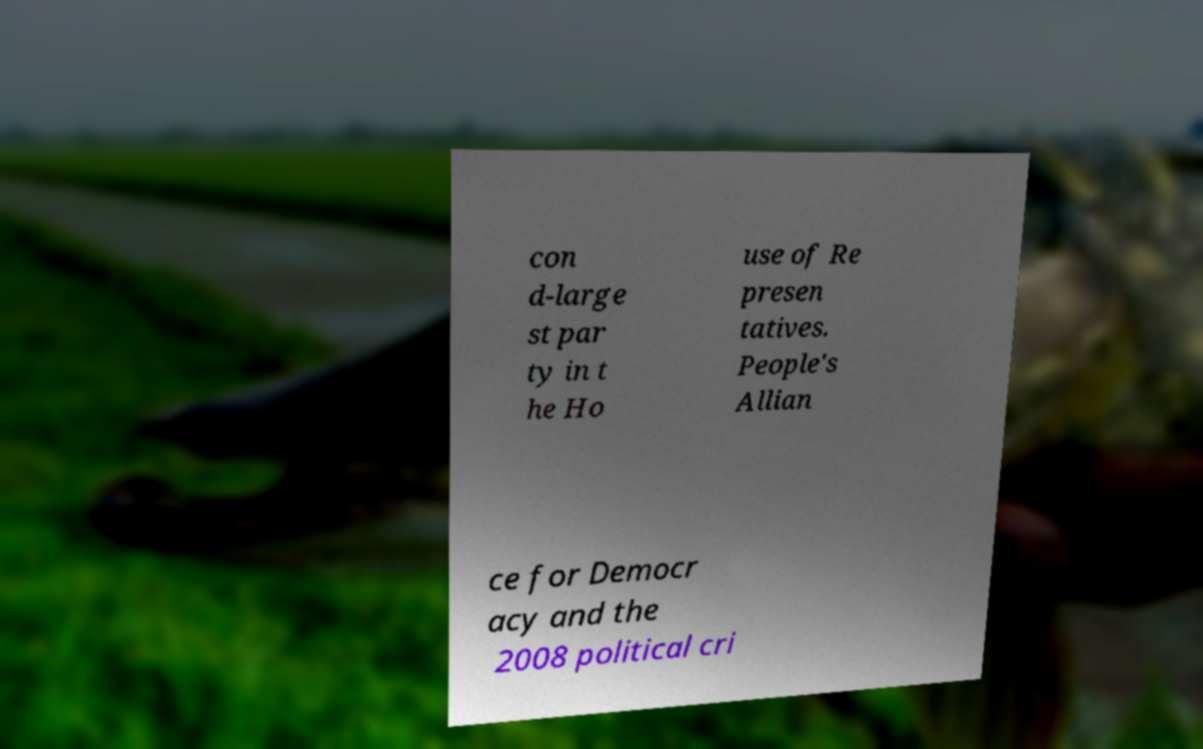What messages or text are displayed in this image? I need them in a readable, typed format. con d-large st par ty in t he Ho use of Re presen tatives. People's Allian ce for Democr acy and the 2008 political cri 